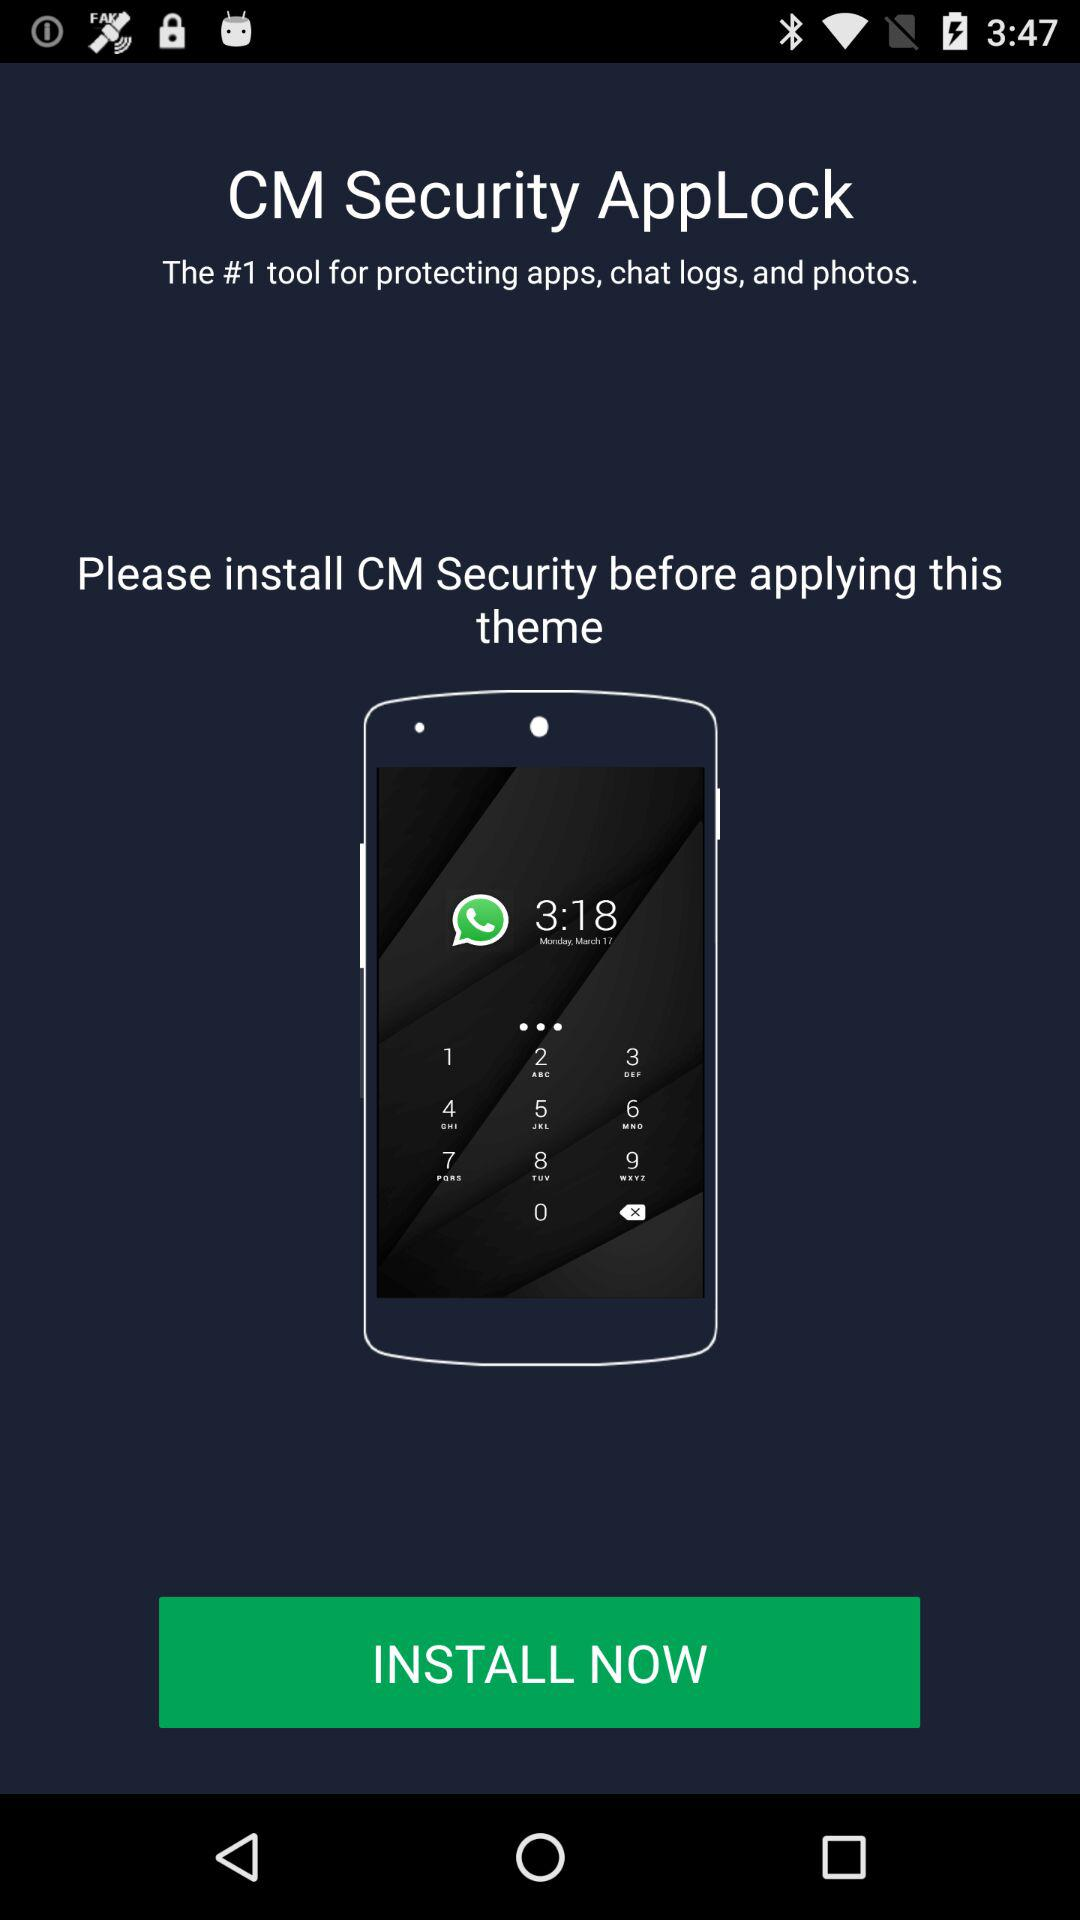What is the application name? The application name is "CM Security AppLock". 